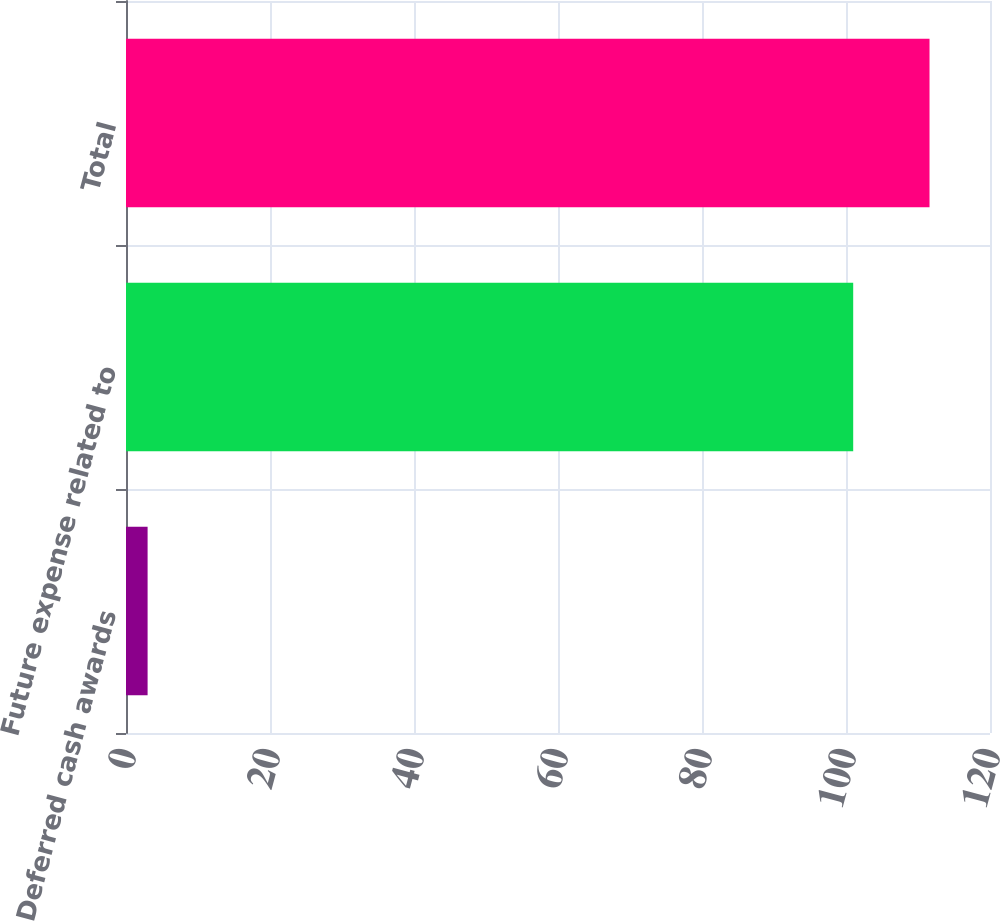Convert chart. <chart><loc_0><loc_0><loc_500><loc_500><bar_chart><fcel>Deferred cash awards<fcel>Future expense related to<fcel>Total<nl><fcel>3<fcel>101<fcel>111.6<nl></chart> 